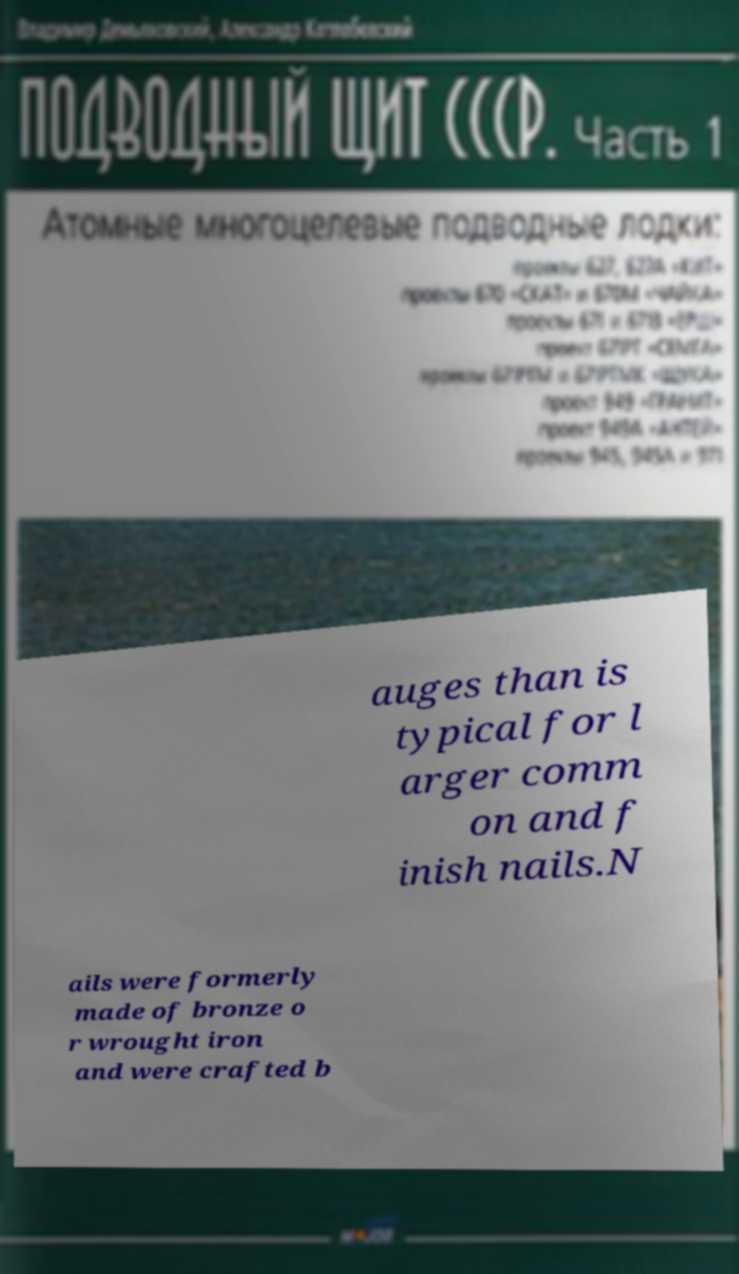Please identify and transcribe the text found in this image. auges than is typical for l arger comm on and f inish nails.N ails were formerly made of bronze o r wrought iron and were crafted b 